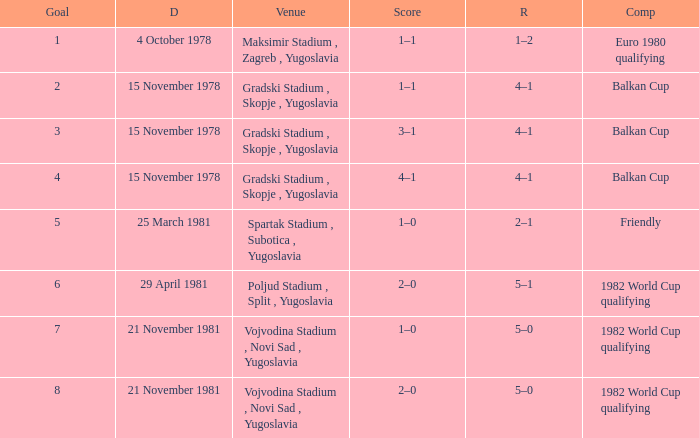What is the Result for Goal 3? 4–1. 